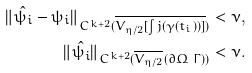<formula> <loc_0><loc_0><loc_500><loc_500>\| \hat { \psi _ { i } } - \psi _ { i } \| _ { C ^ { k + 2 } ( \overline { V _ { \eta / 2 } [ \int j ( \gamma ( t _ { i } ) ) ] } ) } < \nu , \\ \| \hat { \psi _ { i } } \| _ { C ^ { k + 2 } ( \overline { V _ { \eta / 2 } } ( \partial \Omega \ \Gamma ) ) } < \nu .</formula> 